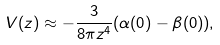Convert formula to latex. <formula><loc_0><loc_0><loc_500><loc_500>V ( z ) \approx - \frac { 3 } { 8 \pi z ^ { 4 } } ( \alpha ( 0 ) - \beta ( 0 ) ) ,</formula> 